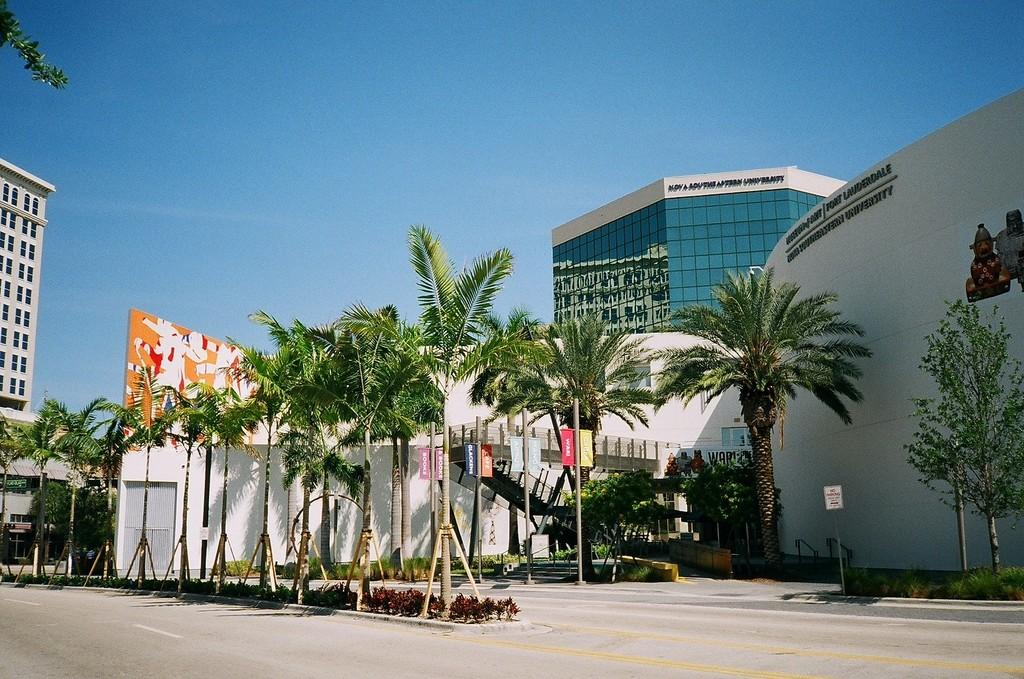What type of vegetation is present in the image? There are trees in the image. What is the color of the trees? The trees are green. What can be seen attached to poles in the image? There are banners attached to poles in the image. What type of structures are visible in the background of the image? There are buildings in the background of the image. What is the color of the sky in the image? The sky is blue. Can you tell me how many balloons are floating above the trees in the image? There are no balloons visible in the image; only trees, banners, buildings, and the sky are present. What type of powder is being used by the police in the image? There are no police or powder present in the image. 